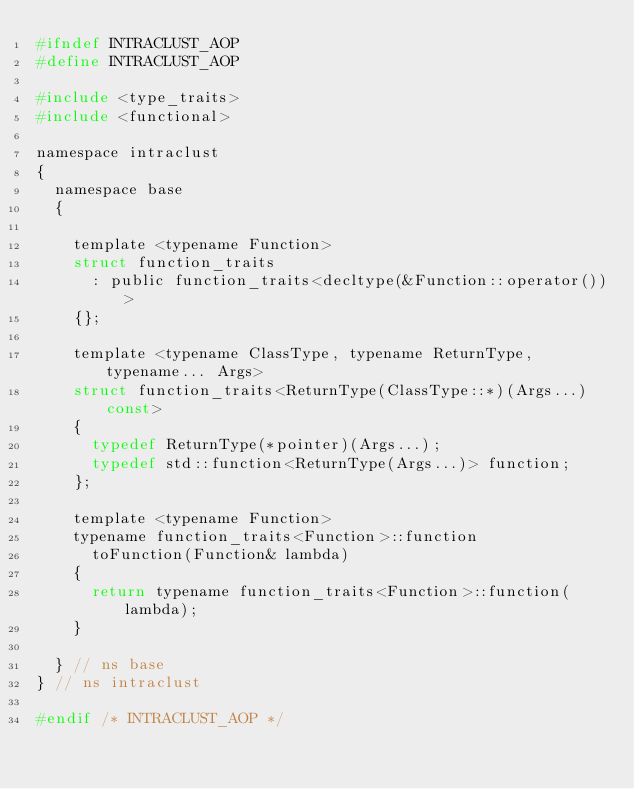<code> <loc_0><loc_0><loc_500><loc_500><_C_>#ifndef INTRACLUST_AOP
#define INTRACLUST_AOP

#include <type_traits>
#include <functional>

namespace intraclust
{
	namespace base
	{

		template <typename Function>
		struct function_traits
			: public function_traits<decltype(&Function::operator())>
		{};

		template <typename ClassType, typename ReturnType, typename... Args>
		struct function_traits<ReturnType(ClassType::*)(Args...) const>
		{
			typedef ReturnType(*pointer)(Args...);
			typedef std::function<ReturnType(Args...)> function;
		};

		template <typename Function>
		typename function_traits<Function>::function
			toFunction(Function& lambda)
		{
			return typename function_traits<Function>::function(lambda);
		}

	} // ns base
} // ns intraclust

#endif /* INTRACLUST_AOP */</code> 